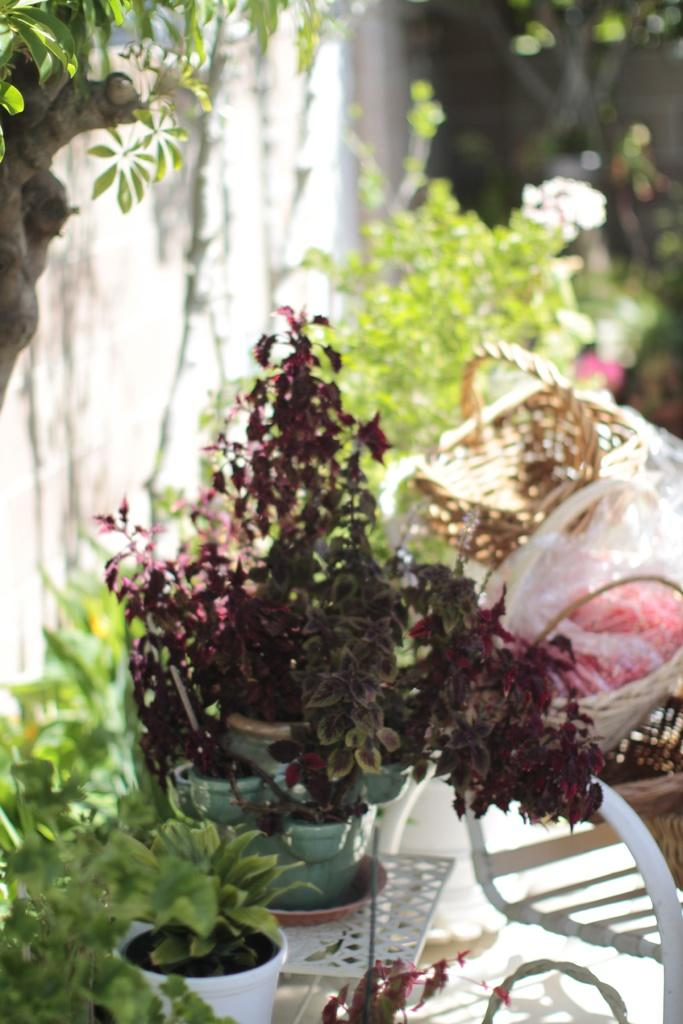What type of plant life is present in the image? There is a tree and plant pots in the image. How are the plant pots arranged in the image? The plant pots are arranged on a stand. Where is the stand located in relation to other objects in the image? The stand is beside a wall. What type of muscle is visible on the tree in the image? There is no muscle visible on the tree in the image, as trees are made of plant material and do not have muscles. 